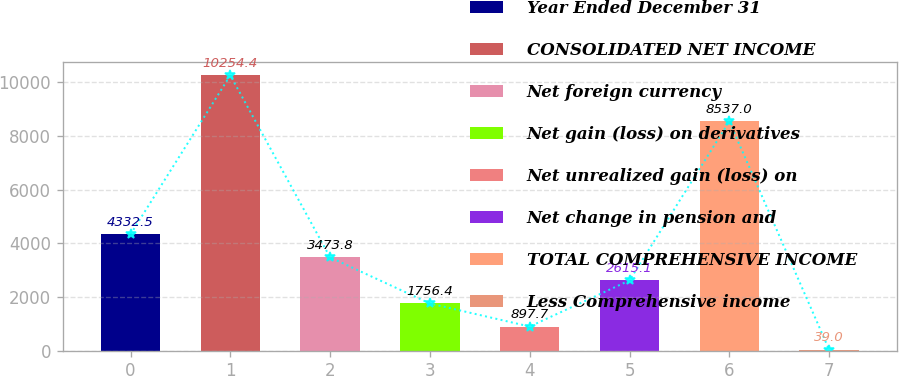Convert chart. <chart><loc_0><loc_0><loc_500><loc_500><bar_chart><fcel>Year Ended December 31<fcel>CONSOLIDATED NET INCOME<fcel>Net foreign currency<fcel>Net gain (loss) on derivatives<fcel>Net unrealized gain (loss) on<fcel>Net change in pension and<fcel>TOTAL COMPREHENSIVE INCOME<fcel>Less Comprehensive income<nl><fcel>4332.5<fcel>10254.4<fcel>3473.8<fcel>1756.4<fcel>897.7<fcel>2615.1<fcel>8537<fcel>39<nl></chart> 